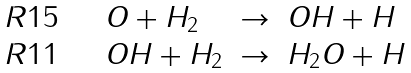Convert formula to latex. <formula><loc_0><loc_0><loc_500><loc_500>\begin{array} { l l c l } R 1 5 \quad & O + H _ { 2 } & \rightarrow & O H + H \\ R 1 1 \quad & O H + H _ { 2 } & \rightarrow & H _ { 2 } O + H \\ \end{array}</formula> 